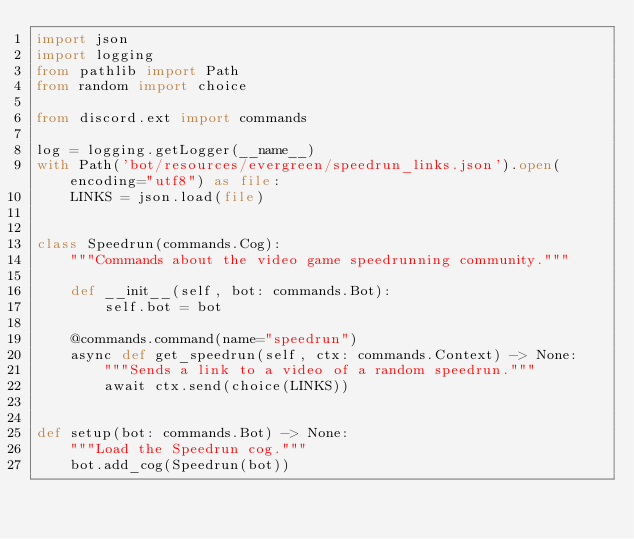Convert code to text. <code><loc_0><loc_0><loc_500><loc_500><_Python_>import json
import logging
from pathlib import Path
from random import choice

from discord.ext import commands

log = logging.getLogger(__name__)
with Path('bot/resources/evergreen/speedrun_links.json').open(encoding="utf8") as file:
    LINKS = json.load(file)


class Speedrun(commands.Cog):
    """Commands about the video game speedrunning community."""

    def __init__(self, bot: commands.Bot):
        self.bot = bot

    @commands.command(name="speedrun")
    async def get_speedrun(self, ctx: commands.Context) -> None:
        """Sends a link to a video of a random speedrun."""
        await ctx.send(choice(LINKS))


def setup(bot: commands.Bot) -> None:
    """Load the Speedrun cog."""
    bot.add_cog(Speedrun(bot))
</code> 